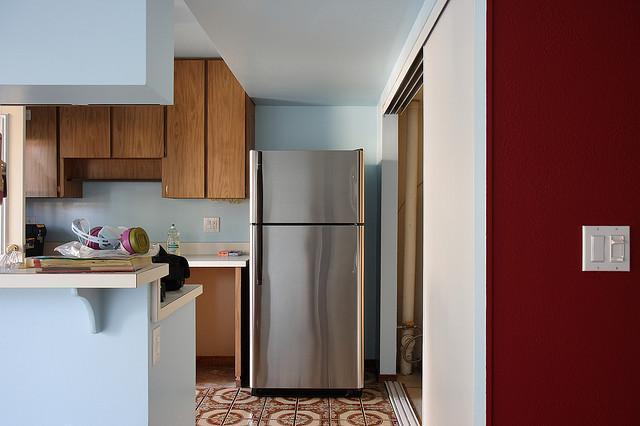How many refrigerators are there?
Give a very brief answer. 1. How many people wearing glasses?
Give a very brief answer. 0. 